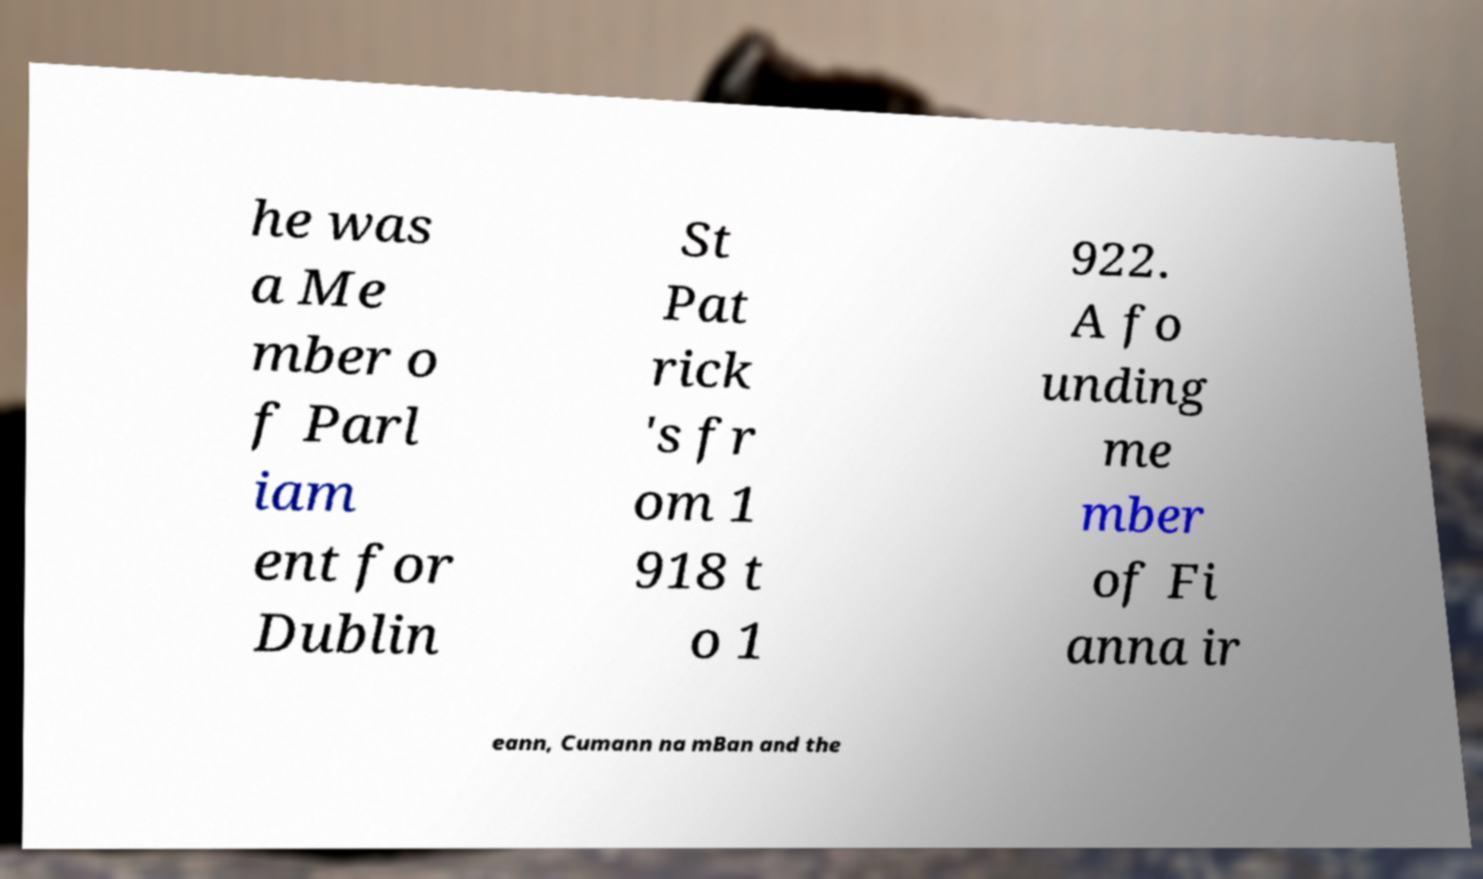Could you assist in decoding the text presented in this image and type it out clearly? he was a Me mber o f Parl iam ent for Dublin St Pat rick 's fr om 1 918 t o 1 922. A fo unding me mber of Fi anna ir eann, Cumann na mBan and the 